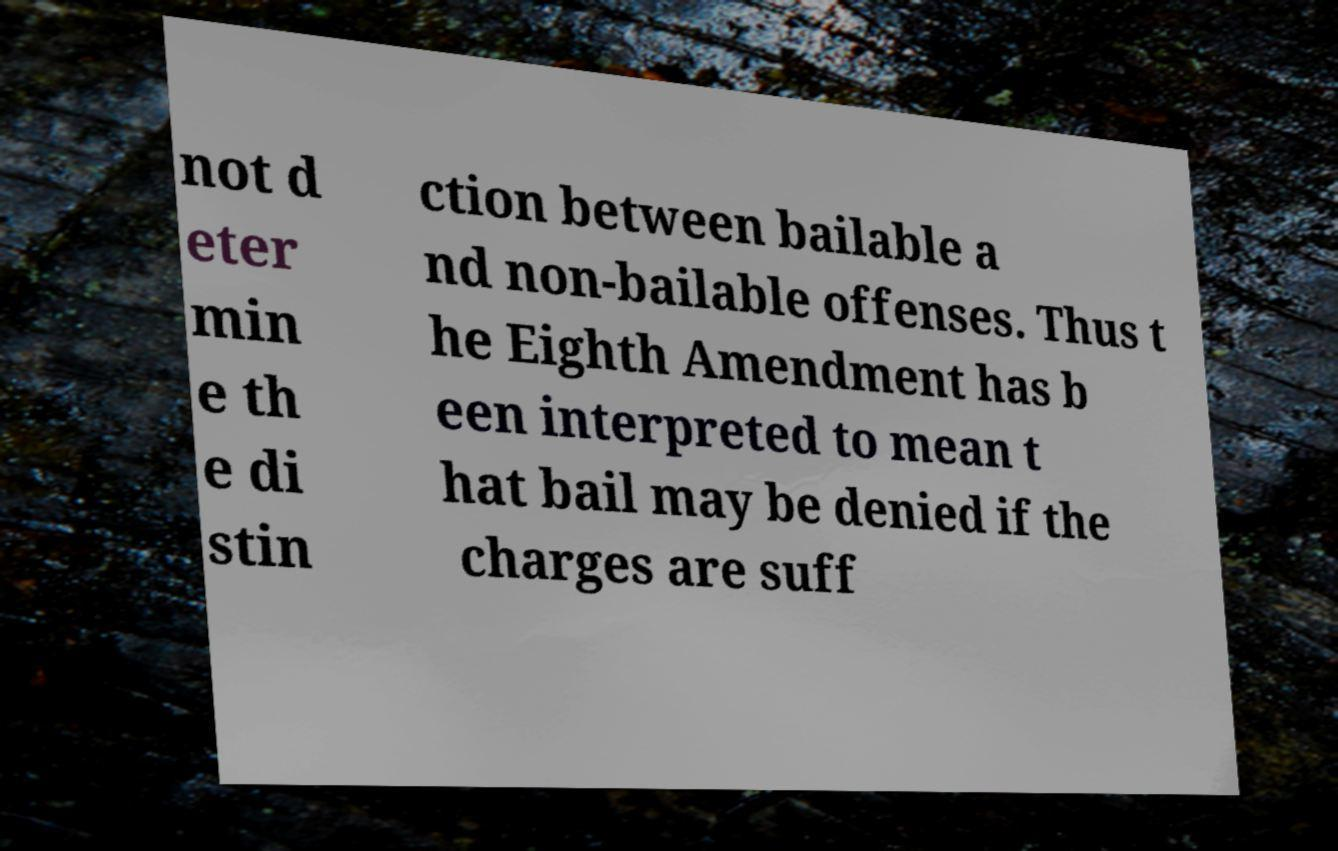Could you extract and type out the text from this image? not d eter min e th e di stin ction between bailable a nd non-bailable offenses. Thus t he Eighth Amendment has b een interpreted to mean t hat bail may be denied if the charges are suff 